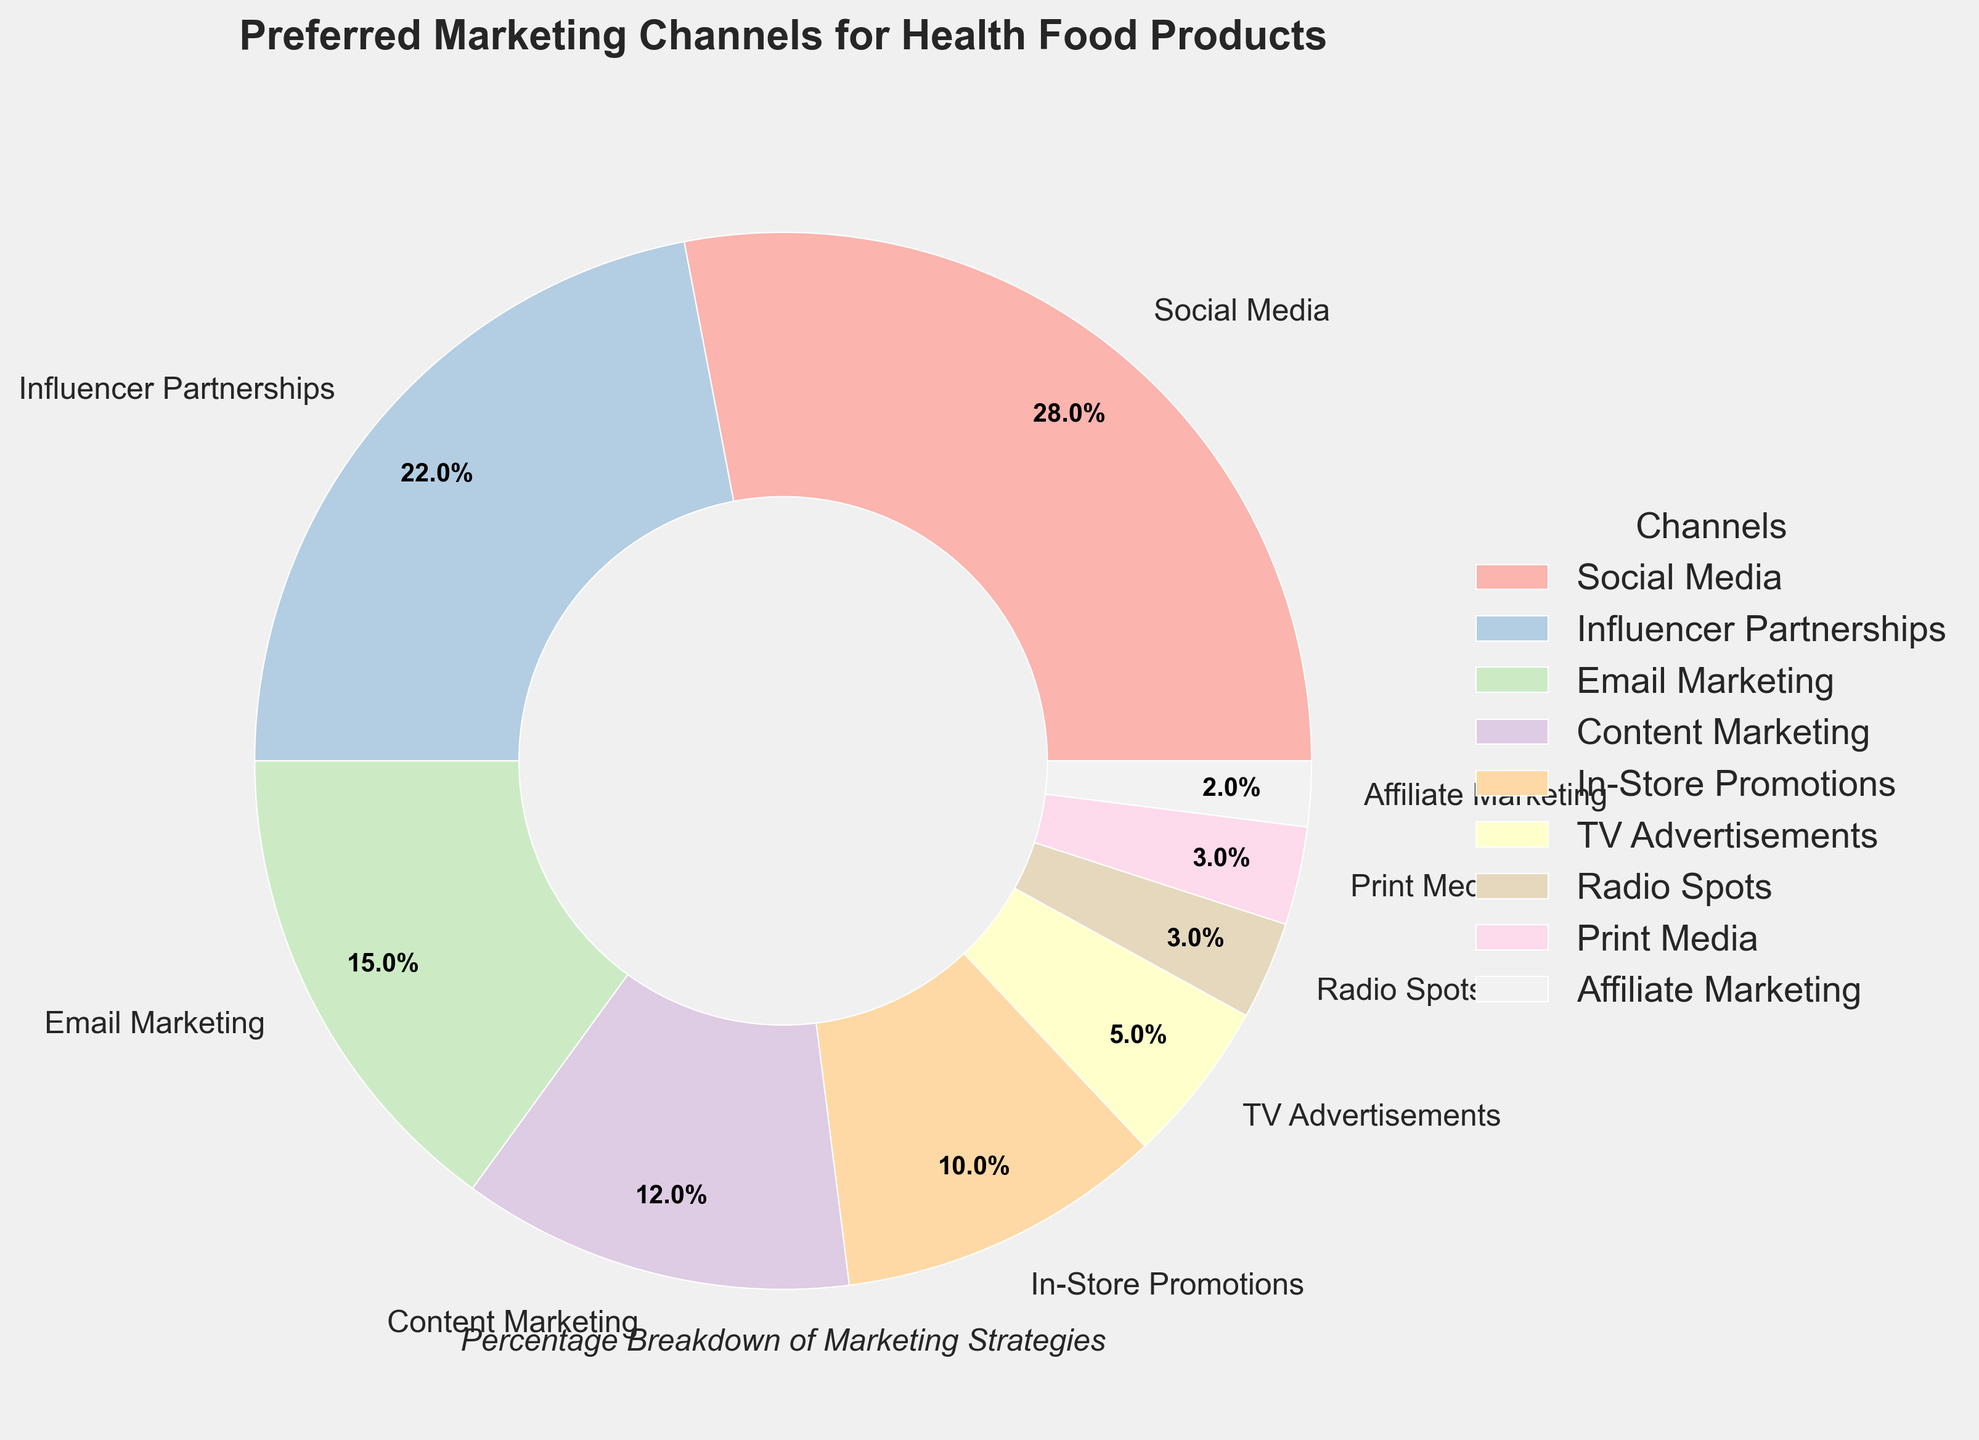Which marketing channel has the highest preference percentage? The chart shows the percentage breakdown of each marketing channel, and the largest wedge corresponds to "Social Media" at 28%.
Answer: Social Media What is the combined percentage of Email Marketing and Content Marketing? According to the chart, Email Marketing is 15% and Content Marketing is 12%. Adding these together gives 15% + 12% = 27%.
Answer: 27% How does the percentage preference for TV Advertisements compare to Radio Spots? TV Advertisements have a preference percentage of 5%, while Radio Spots have a percentage of 3%. Comparing these, 5% is greater than 3%.
Answer: TV Advertisements have a higher percentage than Radio Spots Which is preferred more: In-Store Promotions or Print Media? In-Store Promotions have a percentage of 10%, whereas Print Media has a percentage of 3%. Since 10% is greater than 3%, In-Store Promotions are preferred more.
Answer: In-Store Promotions What is the total percentage for channels with single-digit preference percentages? The single-digit preference percentages are for TV Advertisements (5%), Radio Spots (3%), Print Media (3%), and Affiliate Marketing (2%). Summing these gives 5% + 3% + 3% + 2% = 13%.
Answer: 13% Is the preference for Social Media more than double that of TV Advertisements? Social Media has a preference of 28%, and TV Advertisements have a preference of 5%. Doubling TV Advertisements' 5% gives 10%, and 28% is indeed more than 10%.
Answer: Yes How much higher is the preference for Influencer Partnerships compared to Affiliate Marketing? Influencer Partnerships have a preference of 22%, and Affiliate Marketing has a preference of 2%. Subtracting these gives 22% - 2% = 20%.
Answer: 20% What are the two least preferred marketing channels? The least preferred marketing channels are those with the smallest percentages. The chart shows that Print Media and Affiliate Marketing each have 3% and 2%, respectively.
Answer: Print Media and Affiliate Marketing Which marketing channel occupies the most area in the pie chart? The segment with the largest area in the pie chart corresponds to the one with the highest percentage, which is Social Media at 28%.
Answer: Social Media What is the difference in percentage between the top and bottom marketing channels? The top marketing channel is Social Media at 28%, and the bottom is Affiliate Marketing at 2%. The difference is 28% - 2% = 26%.
Answer: 26% 